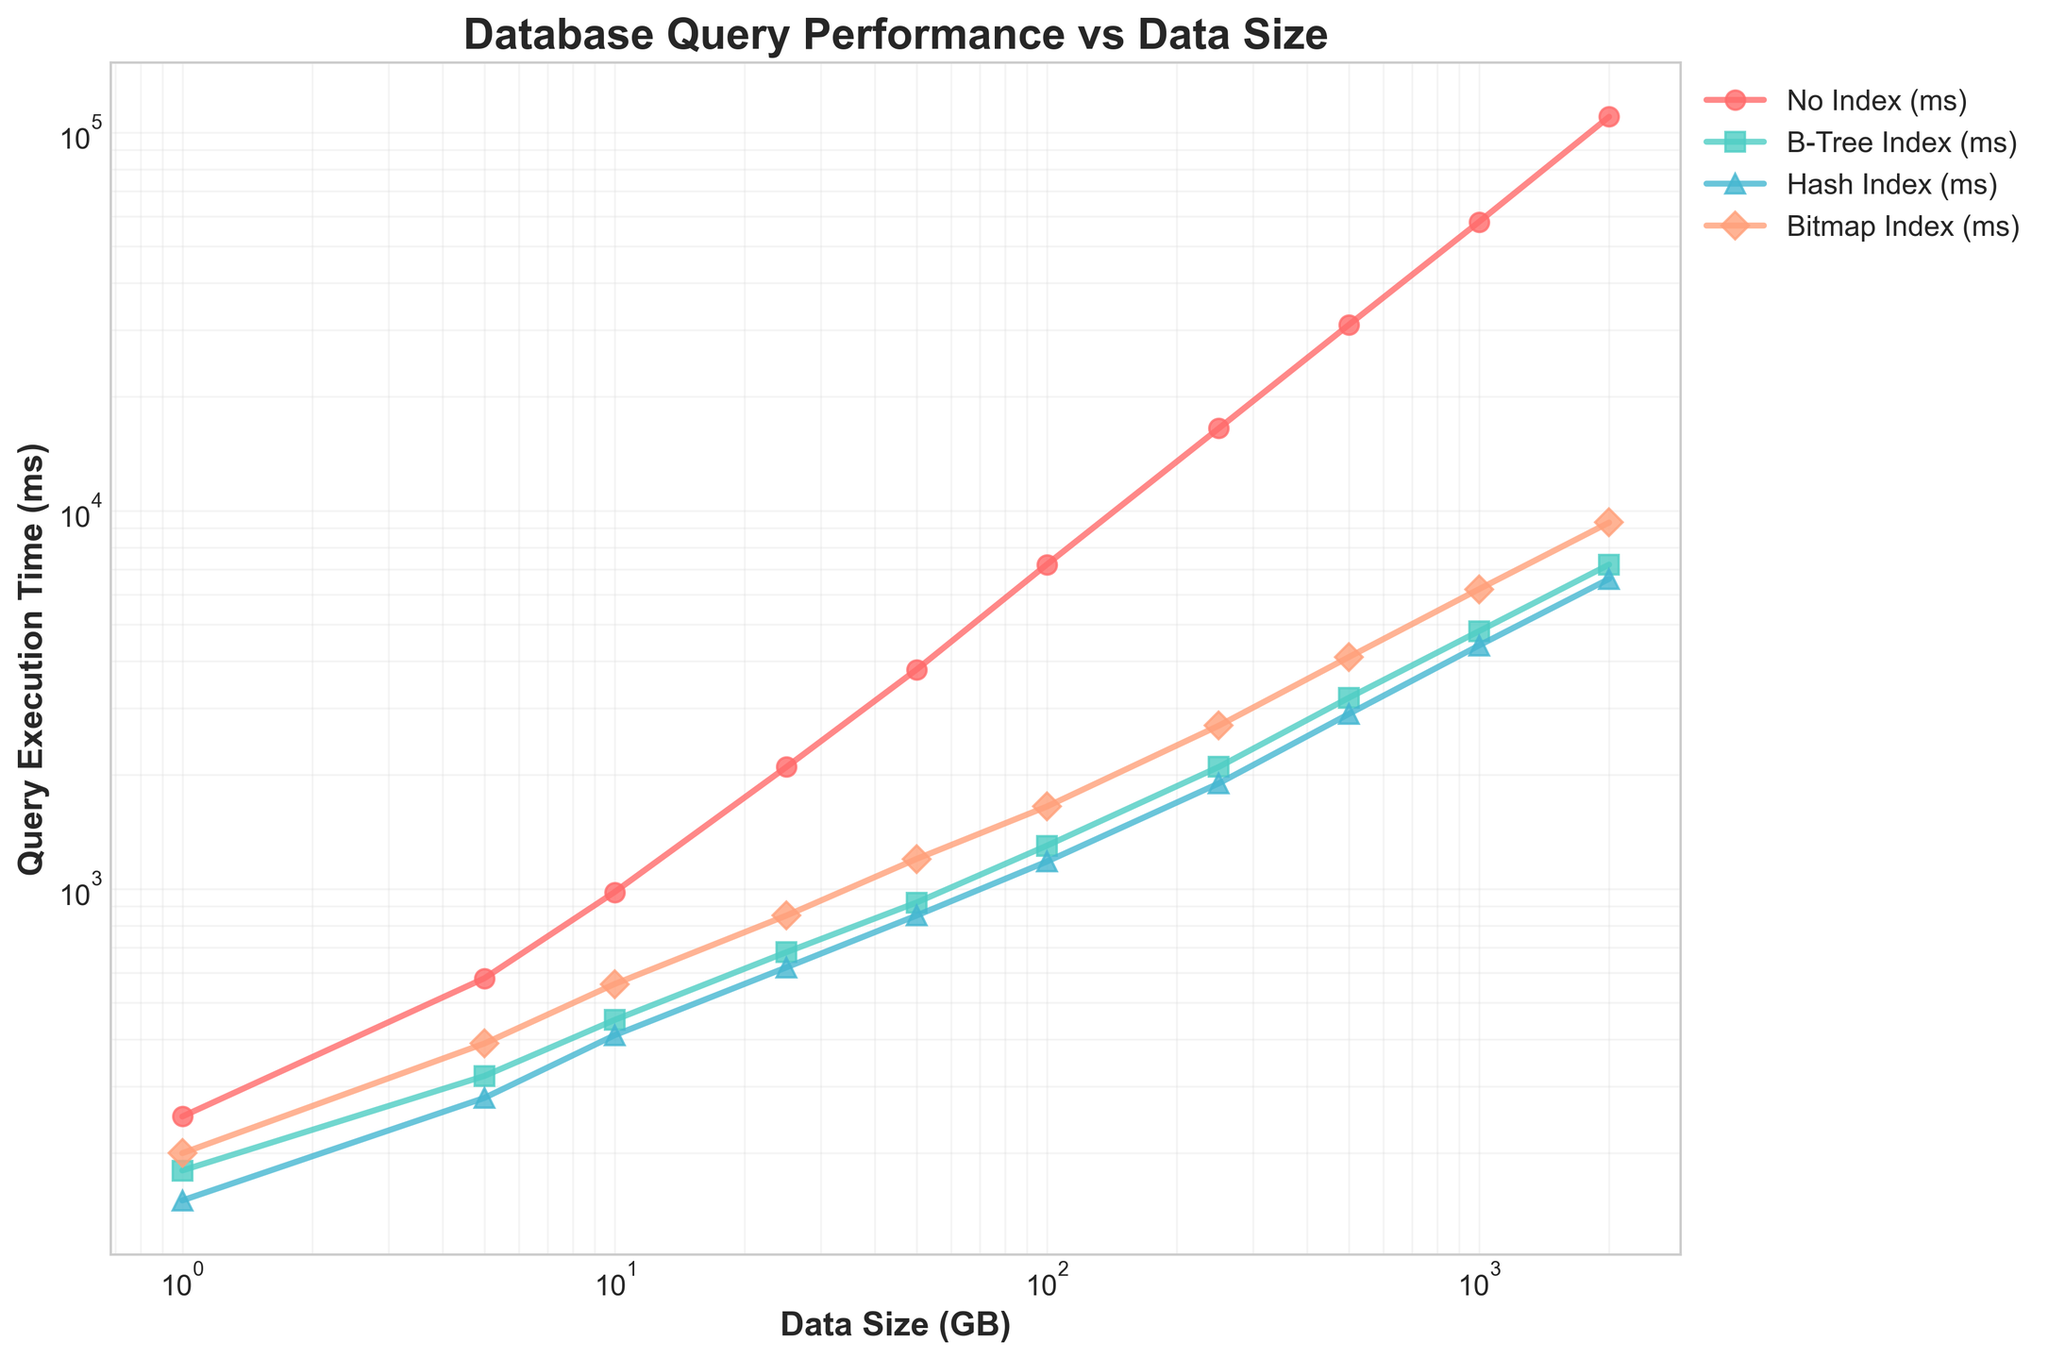Which indexing strategy has the lowest query execution time at a data size of 1 GB? Look at the data points for 1 GB data size and compare the execution times for each indexing strategy. The lowest value is 150 ms for Hash Index.
Answer: Hash Index How does the query execution time for No Index change as the data size grows from 1 GB to 500 GB? Observe the No Index data points and see the execution times at 1 GB (250 ms) and 500 GB (31000 ms). Calculate the difference which is 31000 - 250 = 30750 ms.
Answer: It increases by 30750 ms At 50 GB, which index performs better: B-Tree Index or Hash Index? Compare the execution times for B-Tree Index (920 ms) and Hash Index (850 ms) at the 50 GB data size. Hash Index has a lower value.
Answer: Hash Index What is the percentage increase in query execution time for B-Tree Index from 100 GB to 2000 GB? Calculate the percentage increase using the formula [(New Value - Old Value) / Old Value] x 100. For B-Tree Index, new value = 7200 ms, old value = 1300 ms. The calculation is [(7200 - 1300) / 1300] x 100 ≈ 453.85%.
Answer: Approximately 453.85% Among all indexing strategies, which has the highest query execution time at 250 GB? Look at the execution times at 250 GB for each index. The highest value is 2700 ms for Bitmap Index.
Answer: Bitmap Index What is the difference in execution times between Hash Index and Bitmap Index at 1000 GB? Compare the execution times for Hash Index (4400 ms) and Bitmap Index (6200 ms) at 1000 GB. The difference is 6200 - 4400 = 1800 ms.
Answer: 1800 ms Is there a data size where the query execution time for the No Index strategy equals or exceeds 10,000 ms? Check the data size points for No Index. For 250 GB: 16500 ms, 500 GB: 31000 ms, 1000 GB: 58000 ms, 2000 GB: 110000 ms. Notice that No Index exceeds 10,000 ms starting at 250 GB.
Answer: Yes, starting at 250 GB Which indexing strategy shows the smallest increase in execution time from 500 GB to 1000 GB? Calculate the increase for each index from 500 GB to 1000 GB: 
- No Index: 58000 - 31000 = 27000 ms
- B-Tree Index: 4800 - 3200 = 1600 ms
- Hash Index: 4400 - 2900 = 1500 ms
- Bitmap Index: 6200 - 4100 = 2100 ms
The smallest increase is for Hash Index with 1500 ms.
Answer: Hash Index 